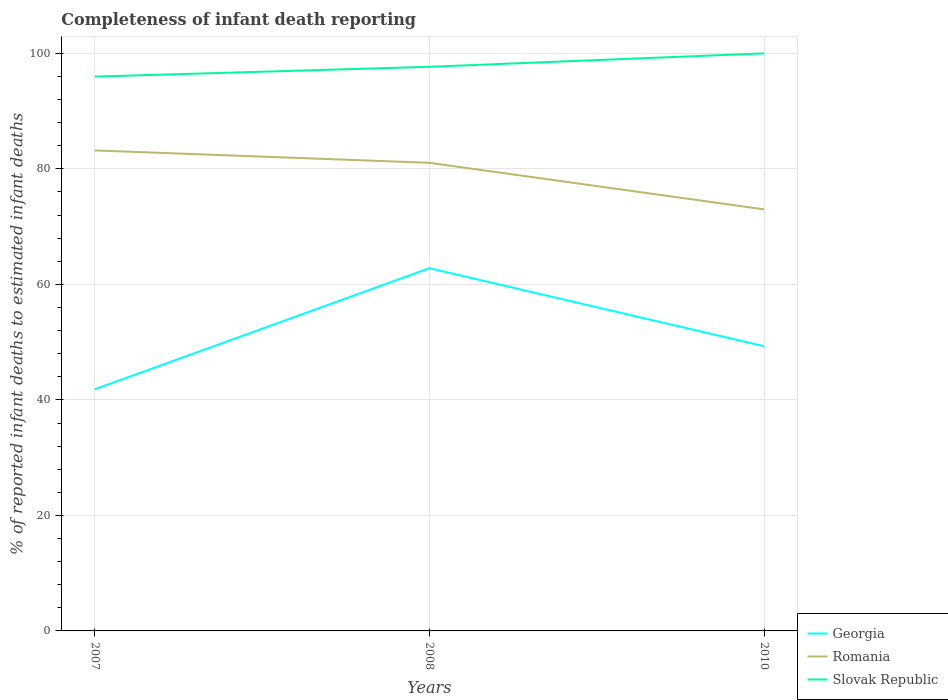How many different coloured lines are there?
Offer a terse response. 3. Is the number of lines equal to the number of legend labels?
Your answer should be compact. Yes. Across all years, what is the maximum percentage of infant deaths reported in Georgia?
Offer a terse response. 41.84. What is the total percentage of infant deaths reported in Romania in the graph?
Keep it short and to the point. 10.2. What is the difference between the highest and the second highest percentage of infant deaths reported in Romania?
Make the answer very short. 10.2. What is the difference between the highest and the lowest percentage of infant deaths reported in Slovak Republic?
Offer a very short reply. 1. Is the percentage of infant deaths reported in Georgia strictly greater than the percentage of infant deaths reported in Slovak Republic over the years?
Your answer should be very brief. Yes. How many lines are there?
Offer a terse response. 3. What is the difference between two consecutive major ticks on the Y-axis?
Give a very brief answer. 20. Are the values on the major ticks of Y-axis written in scientific E-notation?
Offer a terse response. No. Where does the legend appear in the graph?
Your answer should be very brief. Bottom right. How are the legend labels stacked?
Your response must be concise. Vertical. What is the title of the graph?
Offer a very short reply. Completeness of infant death reporting. What is the label or title of the Y-axis?
Provide a succinct answer. % of reported infant deaths to estimated infant deaths. What is the % of reported infant deaths to estimated infant deaths of Georgia in 2007?
Offer a terse response. 41.84. What is the % of reported infant deaths to estimated infant deaths in Romania in 2007?
Ensure brevity in your answer.  83.19. What is the % of reported infant deaths to estimated infant deaths of Slovak Republic in 2007?
Give a very brief answer. 95.98. What is the % of reported infant deaths to estimated infant deaths in Georgia in 2008?
Give a very brief answer. 62.8. What is the % of reported infant deaths to estimated infant deaths of Romania in 2008?
Provide a succinct answer. 81.05. What is the % of reported infant deaths to estimated infant deaths in Slovak Republic in 2008?
Offer a very short reply. 97.67. What is the % of reported infant deaths to estimated infant deaths of Georgia in 2010?
Your response must be concise. 49.3. What is the % of reported infant deaths to estimated infant deaths of Romania in 2010?
Keep it short and to the point. 72.99. Across all years, what is the maximum % of reported infant deaths to estimated infant deaths of Georgia?
Keep it short and to the point. 62.8. Across all years, what is the maximum % of reported infant deaths to estimated infant deaths in Romania?
Give a very brief answer. 83.19. Across all years, what is the minimum % of reported infant deaths to estimated infant deaths in Georgia?
Your response must be concise. 41.84. Across all years, what is the minimum % of reported infant deaths to estimated infant deaths in Romania?
Your answer should be compact. 72.99. Across all years, what is the minimum % of reported infant deaths to estimated infant deaths of Slovak Republic?
Offer a very short reply. 95.98. What is the total % of reported infant deaths to estimated infant deaths in Georgia in the graph?
Provide a short and direct response. 153.94. What is the total % of reported infant deaths to estimated infant deaths in Romania in the graph?
Provide a succinct answer. 237.23. What is the total % of reported infant deaths to estimated infant deaths in Slovak Republic in the graph?
Provide a short and direct response. 293.65. What is the difference between the % of reported infant deaths to estimated infant deaths of Georgia in 2007 and that in 2008?
Provide a short and direct response. -20.97. What is the difference between the % of reported infant deaths to estimated infant deaths in Romania in 2007 and that in 2008?
Your answer should be compact. 2.14. What is the difference between the % of reported infant deaths to estimated infant deaths in Slovak Republic in 2007 and that in 2008?
Ensure brevity in your answer.  -1.7. What is the difference between the % of reported infant deaths to estimated infant deaths in Georgia in 2007 and that in 2010?
Offer a terse response. -7.46. What is the difference between the % of reported infant deaths to estimated infant deaths of Romania in 2007 and that in 2010?
Offer a terse response. 10.2. What is the difference between the % of reported infant deaths to estimated infant deaths of Slovak Republic in 2007 and that in 2010?
Your answer should be very brief. -4.02. What is the difference between the % of reported infant deaths to estimated infant deaths in Georgia in 2008 and that in 2010?
Provide a succinct answer. 13.51. What is the difference between the % of reported infant deaths to estimated infant deaths in Romania in 2008 and that in 2010?
Make the answer very short. 8.06. What is the difference between the % of reported infant deaths to estimated infant deaths in Slovak Republic in 2008 and that in 2010?
Offer a very short reply. -2.33. What is the difference between the % of reported infant deaths to estimated infant deaths in Georgia in 2007 and the % of reported infant deaths to estimated infant deaths in Romania in 2008?
Your answer should be compact. -39.22. What is the difference between the % of reported infant deaths to estimated infant deaths of Georgia in 2007 and the % of reported infant deaths to estimated infant deaths of Slovak Republic in 2008?
Offer a very short reply. -55.84. What is the difference between the % of reported infant deaths to estimated infant deaths in Romania in 2007 and the % of reported infant deaths to estimated infant deaths in Slovak Republic in 2008?
Your response must be concise. -14.48. What is the difference between the % of reported infant deaths to estimated infant deaths in Georgia in 2007 and the % of reported infant deaths to estimated infant deaths in Romania in 2010?
Your answer should be very brief. -31.15. What is the difference between the % of reported infant deaths to estimated infant deaths in Georgia in 2007 and the % of reported infant deaths to estimated infant deaths in Slovak Republic in 2010?
Make the answer very short. -58.16. What is the difference between the % of reported infant deaths to estimated infant deaths in Romania in 2007 and the % of reported infant deaths to estimated infant deaths in Slovak Republic in 2010?
Make the answer very short. -16.81. What is the difference between the % of reported infant deaths to estimated infant deaths of Georgia in 2008 and the % of reported infant deaths to estimated infant deaths of Romania in 2010?
Ensure brevity in your answer.  -10.19. What is the difference between the % of reported infant deaths to estimated infant deaths of Georgia in 2008 and the % of reported infant deaths to estimated infant deaths of Slovak Republic in 2010?
Give a very brief answer. -37.2. What is the difference between the % of reported infant deaths to estimated infant deaths in Romania in 2008 and the % of reported infant deaths to estimated infant deaths in Slovak Republic in 2010?
Keep it short and to the point. -18.95. What is the average % of reported infant deaths to estimated infant deaths in Georgia per year?
Offer a terse response. 51.31. What is the average % of reported infant deaths to estimated infant deaths in Romania per year?
Give a very brief answer. 79.08. What is the average % of reported infant deaths to estimated infant deaths in Slovak Republic per year?
Give a very brief answer. 97.88. In the year 2007, what is the difference between the % of reported infant deaths to estimated infant deaths in Georgia and % of reported infant deaths to estimated infant deaths in Romania?
Offer a very short reply. -41.36. In the year 2007, what is the difference between the % of reported infant deaths to estimated infant deaths in Georgia and % of reported infant deaths to estimated infant deaths in Slovak Republic?
Provide a short and direct response. -54.14. In the year 2007, what is the difference between the % of reported infant deaths to estimated infant deaths in Romania and % of reported infant deaths to estimated infant deaths in Slovak Republic?
Ensure brevity in your answer.  -12.78. In the year 2008, what is the difference between the % of reported infant deaths to estimated infant deaths of Georgia and % of reported infant deaths to estimated infant deaths of Romania?
Offer a terse response. -18.25. In the year 2008, what is the difference between the % of reported infant deaths to estimated infant deaths in Georgia and % of reported infant deaths to estimated infant deaths in Slovak Republic?
Provide a succinct answer. -34.87. In the year 2008, what is the difference between the % of reported infant deaths to estimated infant deaths in Romania and % of reported infant deaths to estimated infant deaths in Slovak Republic?
Provide a short and direct response. -16.62. In the year 2010, what is the difference between the % of reported infant deaths to estimated infant deaths in Georgia and % of reported infant deaths to estimated infant deaths in Romania?
Ensure brevity in your answer.  -23.69. In the year 2010, what is the difference between the % of reported infant deaths to estimated infant deaths in Georgia and % of reported infant deaths to estimated infant deaths in Slovak Republic?
Make the answer very short. -50.7. In the year 2010, what is the difference between the % of reported infant deaths to estimated infant deaths of Romania and % of reported infant deaths to estimated infant deaths of Slovak Republic?
Your answer should be compact. -27.01. What is the ratio of the % of reported infant deaths to estimated infant deaths of Georgia in 2007 to that in 2008?
Offer a terse response. 0.67. What is the ratio of the % of reported infant deaths to estimated infant deaths in Romania in 2007 to that in 2008?
Provide a short and direct response. 1.03. What is the ratio of the % of reported infant deaths to estimated infant deaths of Slovak Republic in 2007 to that in 2008?
Provide a succinct answer. 0.98. What is the ratio of the % of reported infant deaths to estimated infant deaths of Georgia in 2007 to that in 2010?
Make the answer very short. 0.85. What is the ratio of the % of reported infant deaths to estimated infant deaths in Romania in 2007 to that in 2010?
Provide a succinct answer. 1.14. What is the ratio of the % of reported infant deaths to estimated infant deaths of Slovak Republic in 2007 to that in 2010?
Give a very brief answer. 0.96. What is the ratio of the % of reported infant deaths to estimated infant deaths in Georgia in 2008 to that in 2010?
Your answer should be compact. 1.27. What is the ratio of the % of reported infant deaths to estimated infant deaths in Romania in 2008 to that in 2010?
Provide a succinct answer. 1.11. What is the ratio of the % of reported infant deaths to estimated infant deaths in Slovak Republic in 2008 to that in 2010?
Provide a succinct answer. 0.98. What is the difference between the highest and the second highest % of reported infant deaths to estimated infant deaths of Georgia?
Give a very brief answer. 13.51. What is the difference between the highest and the second highest % of reported infant deaths to estimated infant deaths in Romania?
Keep it short and to the point. 2.14. What is the difference between the highest and the second highest % of reported infant deaths to estimated infant deaths in Slovak Republic?
Offer a very short reply. 2.33. What is the difference between the highest and the lowest % of reported infant deaths to estimated infant deaths of Georgia?
Keep it short and to the point. 20.97. What is the difference between the highest and the lowest % of reported infant deaths to estimated infant deaths in Romania?
Provide a short and direct response. 10.2. What is the difference between the highest and the lowest % of reported infant deaths to estimated infant deaths of Slovak Republic?
Ensure brevity in your answer.  4.02. 